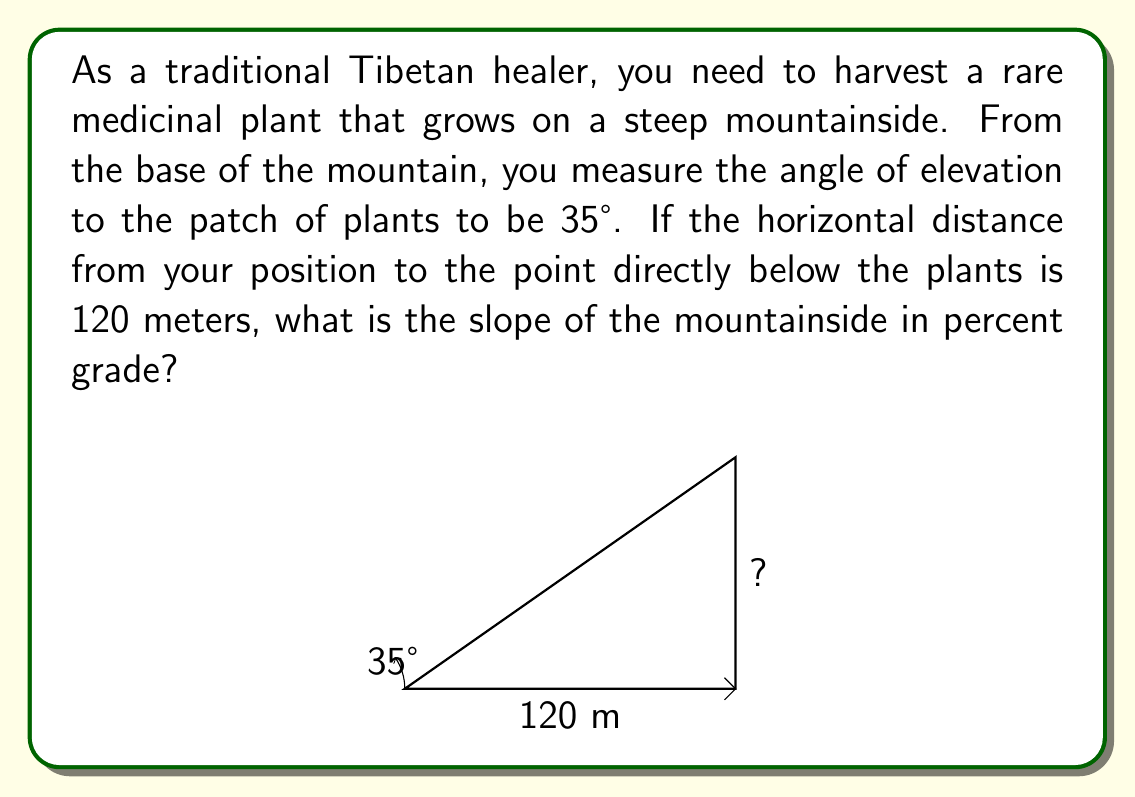Provide a solution to this math problem. To solve this problem, we'll use trigonometry and the definition of percent grade. Let's break it down step-by-step:

1) First, we need to find the vertical rise of the mountainside. We can use the tangent function for this:

   $\tan(\theta) = \frac{\text{opposite}}{\text{adjacent}} = \frac{\text{rise}}{\text{run}}$

2) We know the angle $\theta = 35°$ and the run (horizontal distance) is 120 meters. Let's call the rise $h$:

   $\tan(35°) = \frac{h}{120}$

3) Solving for $h$:

   $h = 120 \cdot \tan(35°)$

4) Using a calculator or trigonometric table:

   $h \approx 120 \cdot 0.7002 \approx 84.02$ meters

5) Now, we need to calculate the percent grade. The percent grade is defined as:

   $\text{Percent Grade} = \frac{\text{rise}}{\text{run}} \cdot 100\%$

6) Plugging in our values:

   $\text{Percent Grade} = \frac{84.02}{120} \cdot 100\% \approx 70.02\%$

Therefore, the slope of the mountainside is approximately 70.02% grade.
Answer: The slope of the mountainside is approximately 70.02% grade. 